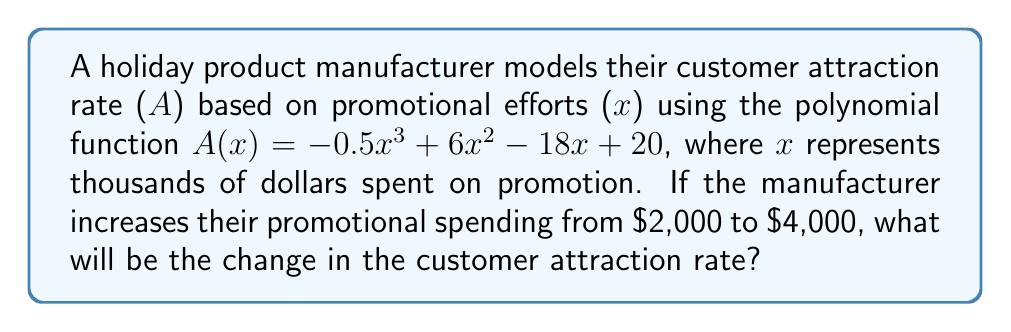Can you solve this math problem? To solve this problem, we need to follow these steps:

1. Calculate A(2), the attraction rate when spending $2,000:
   $A(2) = -0.5(2)^3 + 6(2)^2 - 18(2) + 20$
   $= -0.5(8) + 6(4) - 36 + 20$
   $= -4 + 24 - 36 + 20$
   $= 4$

2. Calculate A(4), the attraction rate when spending $4,000:
   $A(4) = -0.5(4)^3 + 6(4)^2 - 18(4) + 20$
   $= -0.5(64) + 6(16) - 72 + 20$
   $= -32 + 96 - 72 + 20$
   $= 12$

3. Calculate the change in attraction rate:
   Change = A(4) - A(2)
   $= 12 - 4$
   $= 8$

Therefore, the change in the customer attraction rate when increasing promotional spending from $2,000 to $4,000 is 8.
Answer: 8 